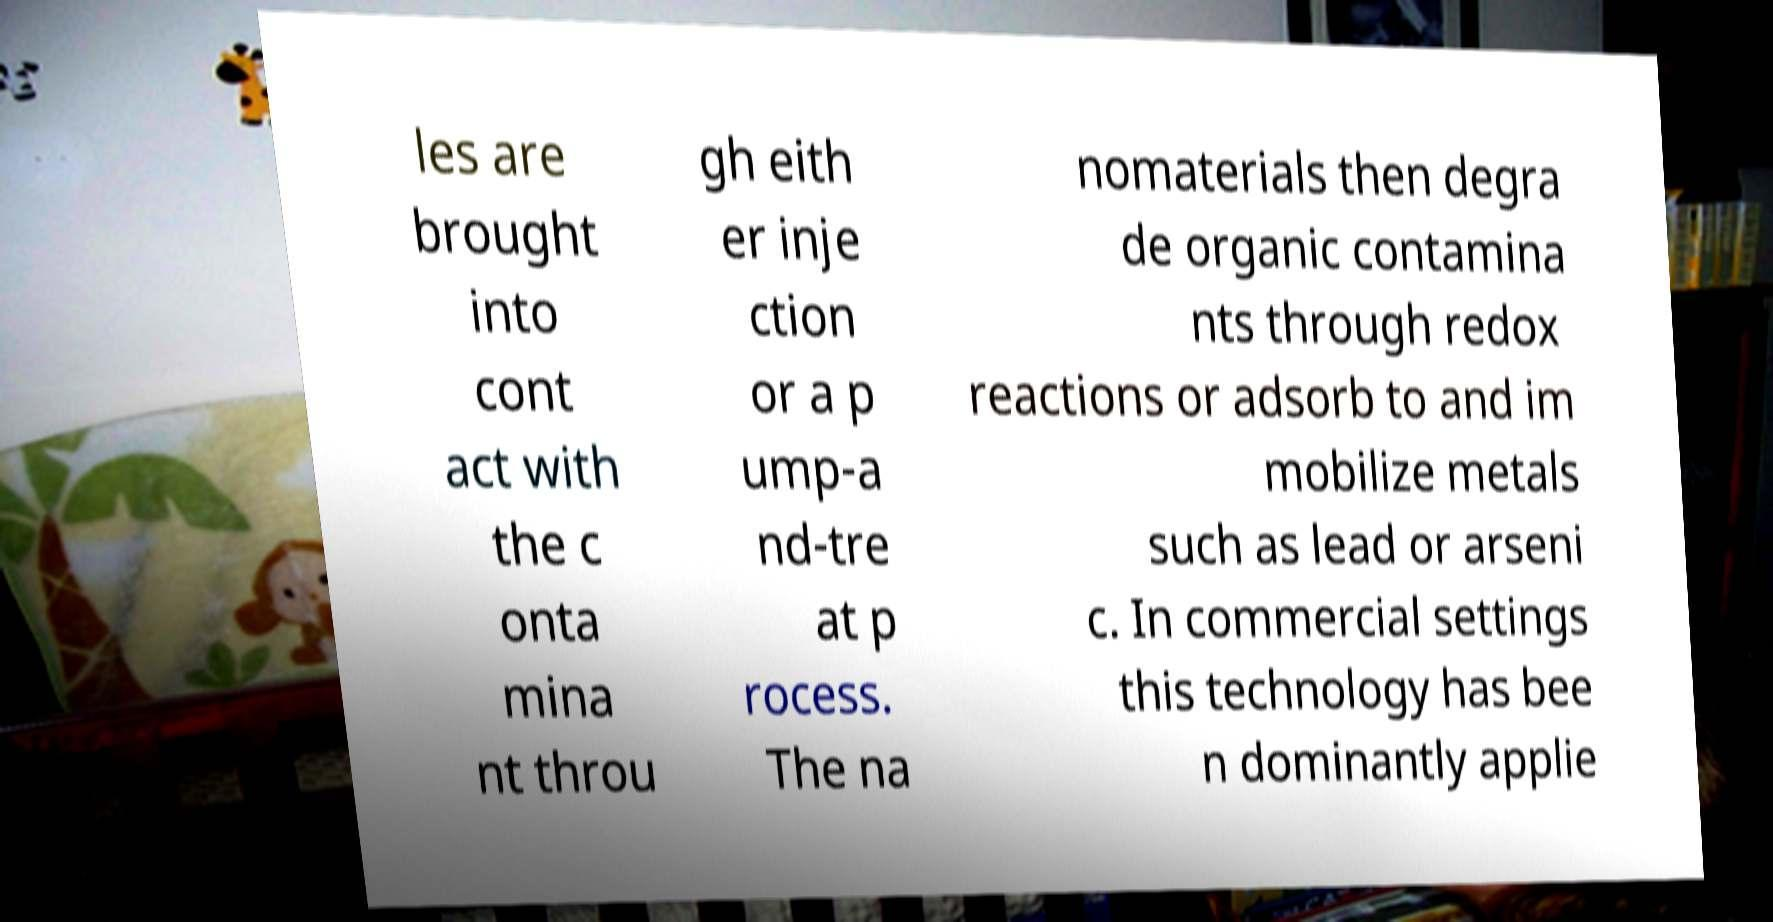Can you accurately transcribe the text from the provided image for me? les are brought into cont act with the c onta mina nt throu gh eith er inje ction or a p ump-a nd-tre at p rocess. The na nomaterials then degra de organic contamina nts through redox reactions or adsorb to and im mobilize metals such as lead or arseni c. In commercial settings this technology has bee n dominantly applie 